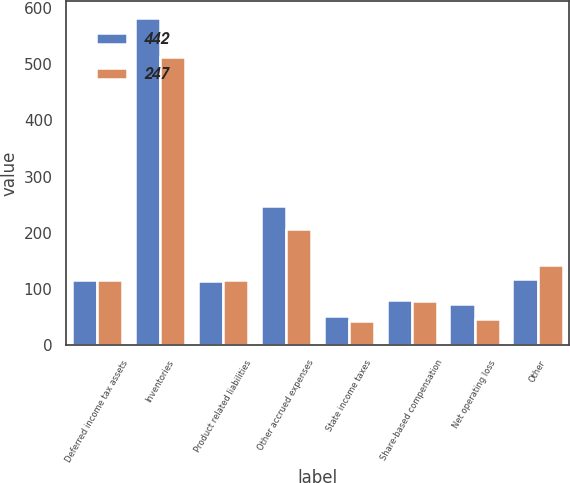Convert chart. <chart><loc_0><loc_0><loc_500><loc_500><stacked_bar_chart><ecel><fcel>Deferred income tax assets<fcel>Inventories<fcel>Product related liabilities<fcel>Other accrued expenses<fcel>State income taxes<fcel>Share-based compensation<fcel>Net operating loss<fcel>Other<nl><fcel>442<fcel>115.5<fcel>583<fcel>115<fcel>248<fcel>52<fcel>80<fcel>74<fcel>117<nl><fcel>247<fcel>115.5<fcel>513<fcel>116<fcel>206<fcel>43<fcel>79<fcel>47<fcel>143<nl></chart> 